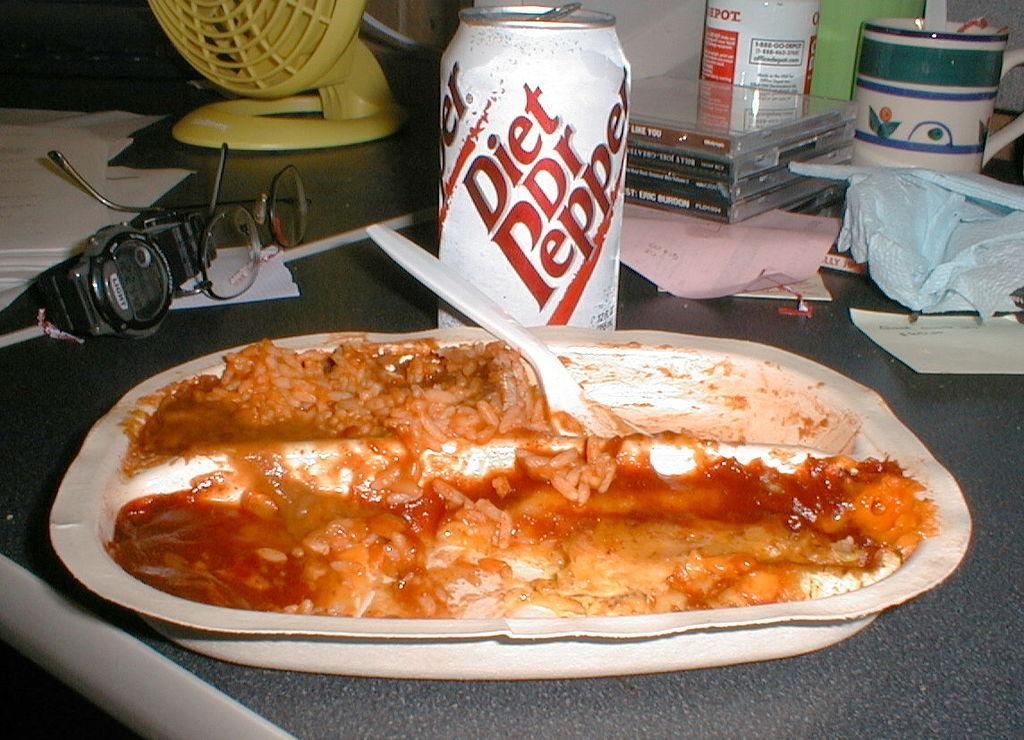Describe this image in one or two sentences. In this image I can see there are food items in a white color plate and a spoon. This is the tin in white color, on the left side there is a watch and spectacles, at the top it looks like a fan in yellow color. 